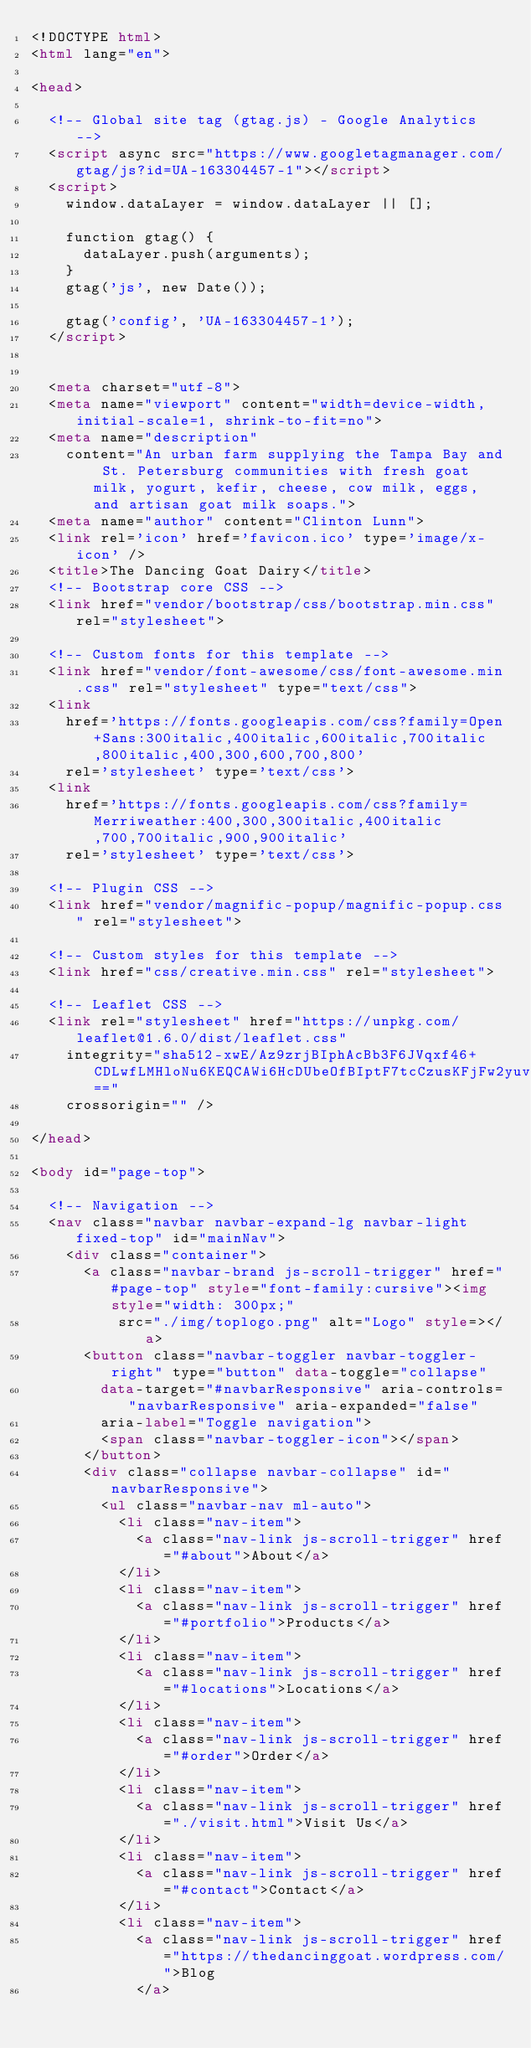Convert code to text. <code><loc_0><loc_0><loc_500><loc_500><_HTML_><!DOCTYPE html>
<html lang="en">

<head>

  <!-- Global site tag (gtag.js) - Google Analytics -->
  <script async src="https://www.googletagmanager.com/gtag/js?id=UA-163304457-1"></script>
  <script>
    window.dataLayer = window.dataLayer || [];

    function gtag() {
      dataLayer.push(arguments);
    }
    gtag('js', new Date());

    gtag('config', 'UA-163304457-1');
  </script>


  <meta charset="utf-8">
  <meta name="viewport" content="width=device-width, initial-scale=1, shrink-to-fit=no">
  <meta name="description"
    content="An urban farm supplying the Tampa Bay and St. Petersburg communities with fresh goat milk, yogurt, kefir, cheese, cow milk, eggs, and artisan goat milk soaps.">
  <meta name="author" content="Clinton Lunn">
  <link rel='icon' href='favicon.ico' type='image/x-icon' />
  <title>The Dancing Goat Dairy</title>
  <!-- Bootstrap core CSS -->
  <link href="vendor/bootstrap/css/bootstrap.min.css" rel="stylesheet">

  <!-- Custom fonts for this template -->
  <link href="vendor/font-awesome/css/font-awesome.min.css" rel="stylesheet" type="text/css">
  <link
    href='https://fonts.googleapis.com/css?family=Open+Sans:300italic,400italic,600italic,700italic,800italic,400,300,600,700,800'
    rel='stylesheet' type='text/css'>
  <link
    href='https://fonts.googleapis.com/css?family=Merriweather:400,300,300italic,400italic,700,700italic,900,900italic'
    rel='stylesheet' type='text/css'>

  <!-- Plugin CSS -->
  <link href="vendor/magnific-popup/magnific-popup.css" rel="stylesheet">

  <!-- Custom styles for this template -->
  <link href="css/creative.min.css" rel="stylesheet">

  <!-- Leaflet CSS -->
  <link rel="stylesheet" href="https://unpkg.com/leaflet@1.6.0/dist/leaflet.css"
    integrity="sha512-xwE/Az9zrjBIphAcBb3F6JVqxf46+CDLwfLMHloNu6KEQCAWi6HcDUbeOfBIptF7tcCzusKFjFw2yuvEpDL9wQ=="
    crossorigin="" />

</head>

<body id="page-top">

  <!-- Navigation -->
  <nav class="navbar navbar-expand-lg navbar-light fixed-top" id="mainNav">
    <div class="container">
      <a class="navbar-brand js-scroll-trigger" href="#page-top" style="font-family:cursive"><img style="width: 300px;"
          src="./img/toplogo.png" alt="Logo" style=></a>
      <button class="navbar-toggler navbar-toggler-right" type="button" data-toggle="collapse"
        data-target="#navbarResponsive" aria-controls="navbarResponsive" aria-expanded="false"
        aria-label="Toggle navigation">
        <span class="navbar-toggler-icon"></span>
      </button>
      <div class="collapse navbar-collapse" id="navbarResponsive">
        <ul class="navbar-nav ml-auto">
          <li class="nav-item">
            <a class="nav-link js-scroll-trigger" href="#about">About</a>
          </li>
          <li class="nav-item">
            <a class="nav-link js-scroll-trigger" href="#portfolio">Products</a>
          </li>
          <li class="nav-item">
            <a class="nav-link js-scroll-trigger" href="#locations">Locations</a>
          </li>
          <li class="nav-item">
            <a class="nav-link js-scroll-trigger" href="#order">Order</a>
          </li>
          <li class="nav-item">
            <a class="nav-link js-scroll-trigger" href="./visit.html">Visit Us</a>
          </li>
          <li class="nav-item">
            <a class="nav-link js-scroll-trigger" href="#contact">Contact</a>
          </li>
          <li class="nav-item">
            <a class="nav-link js-scroll-trigger" href="https://thedancinggoat.wordpress.com/">Blog
            </a></code> 